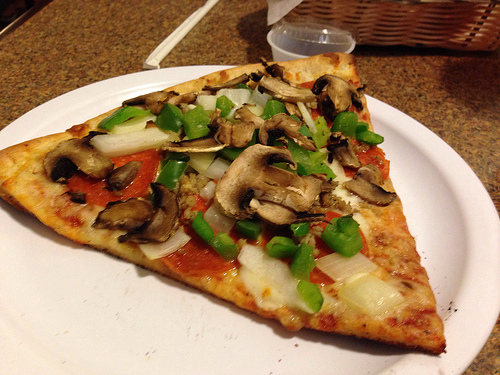If this scene were part of an art piece, what title would you give it? A Slice of Simplicity: Culinary Delights and Rustic Charm If you were to create a story based on this image, what would the plot be? In a quaint, cozy European village, a talented chef named Maria prepares a pizza using vegetables she handpicked from her garden that morning. The pizza, topped with mushrooms, green bell peppers, onions, and pepperoni, becomes the centerpiece of an impromptu gathering of villagers, who arrive bearing baskets of fresh bread and homemade dips. What starts as an ordinary day turns into a joyous celebration of food, community, and lifelong friendships. 